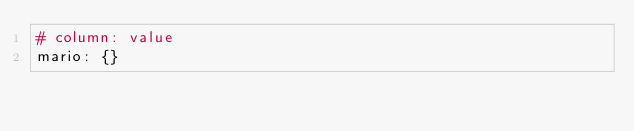Convert code to text. <code><loc_0><loc_0><loc_500><loc_500><_YAML_># column: value
mario: {}
</code> 